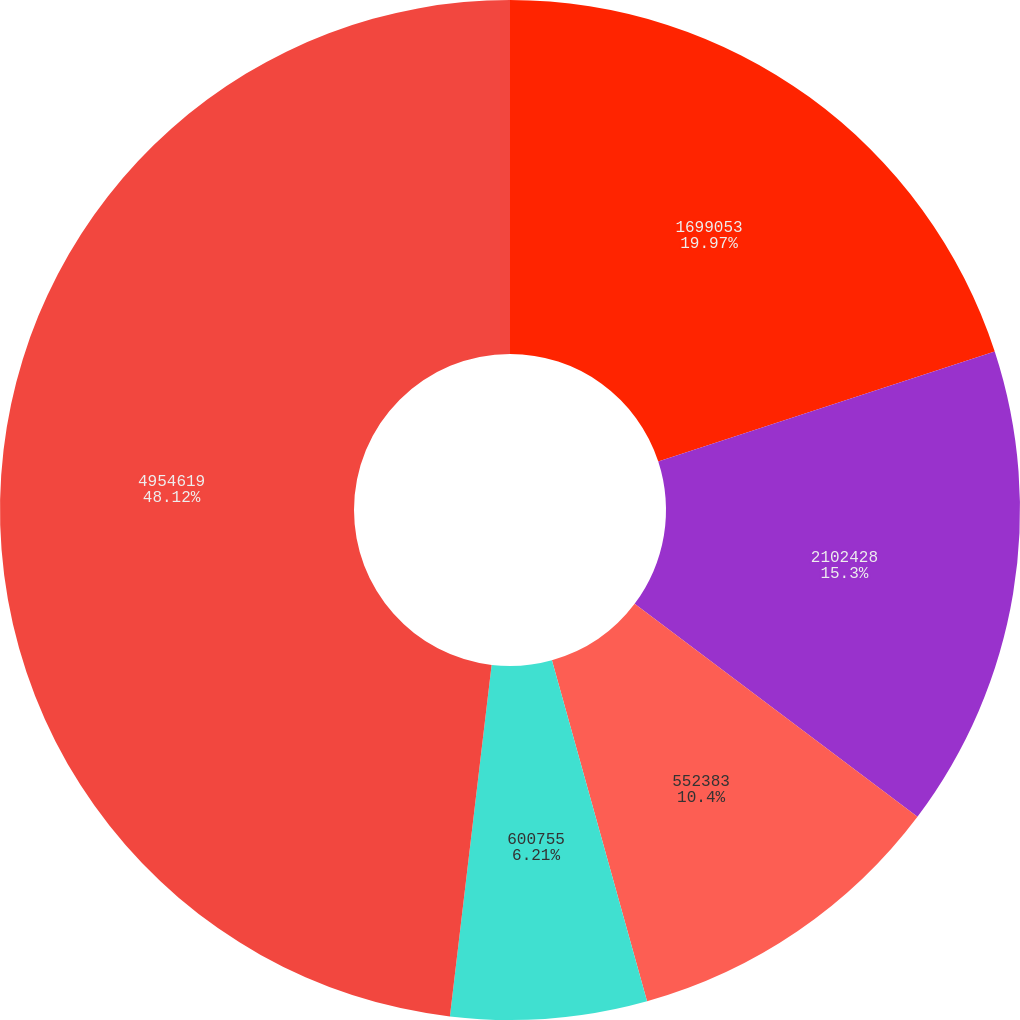Convert chart. <chart><loc_0><loc_0><loc_500><loc_500><pie_chart><fcel>1699053<fcel>2102428<fcel>552383<fcel>600755<fcel>4954619<nl><fcel>19.97%<fcel>15.3%<fcel>10.4%<fcel>6.21%<fcel>48.12%<nl></chart> 